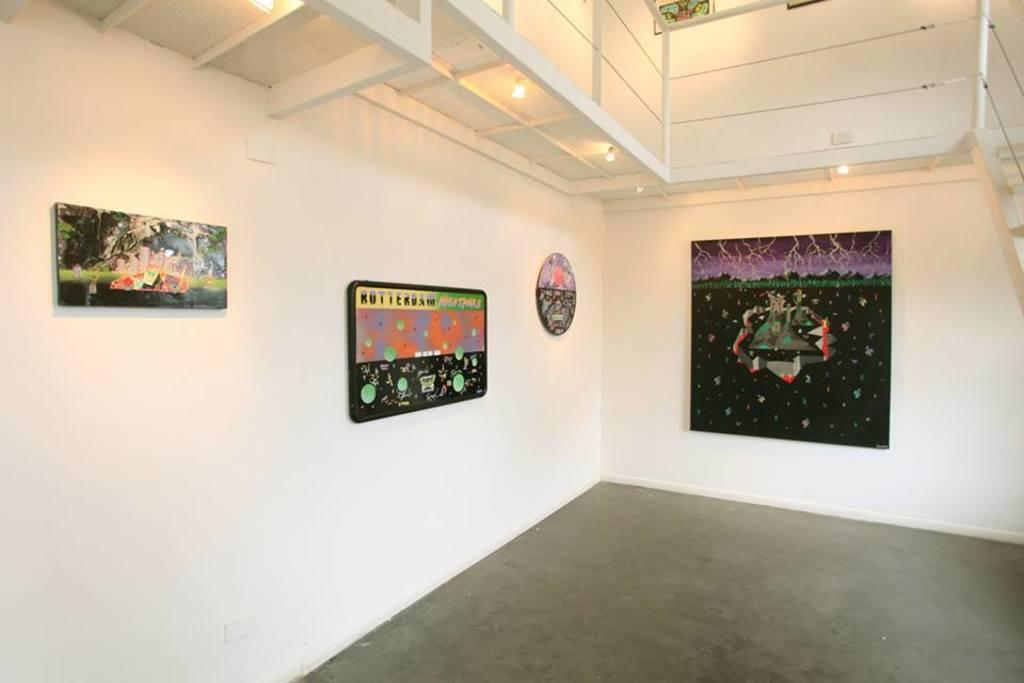What is attached to the wall in the image? There are frames attached to the wall in the image. What type of illumination is present in the image? There are lights in the image. What architectural feature is visible in the image? There are stairs in the image. What religious symbols can be seen on the frames in the image? There is no mention of religious symbols in the image; it only features frames attached to the wall. Is there any blood visible on the stairs in the image? There is no blood visible in the image; it only features stairs as an architectural feature. 